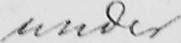Can you tell me what this handwritten text says? under 